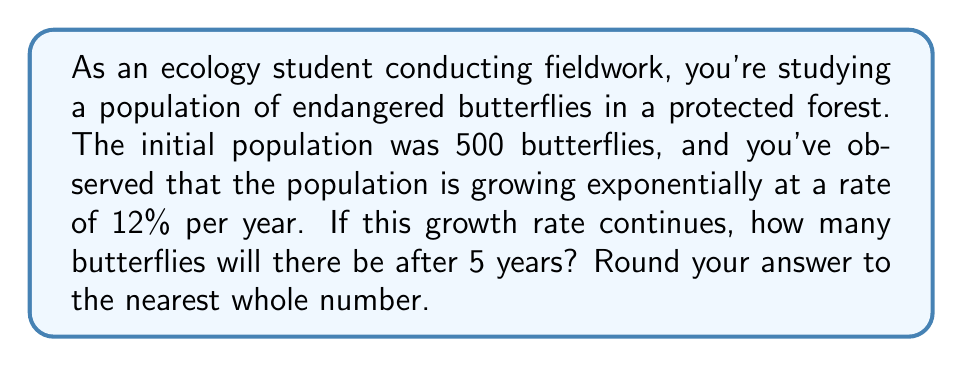Provide a solution to this math problem. To solve this problem, we'll use the exponential growth model:

$$A = P(1 + r)^t$$

Where:
$A$ = Final amount (population after 5 years)
$P$ = Initial population (500 butterflies)
$r$ = Growth rate (12% = 0.12)
$t$ = Time period (5 years)

Let's plug in the values:

$$A = 500(1 + 0.12)^5$$

Now, let's solve step-by-step:

1) First, calculate $(1 + 0.12)^5$:
   $$(1.12)^5 = 1.7623416$$

2) Multiply this result by the initial population:
   $$500 \times 1.7623416 = 881.1708$$

3) Round to the nearest whole number:
   $$881.1708 \approx 881$$

Therefore, after 5 years, there will be approximately 881 butterflies in the population.
Answer: 881 butterflies 